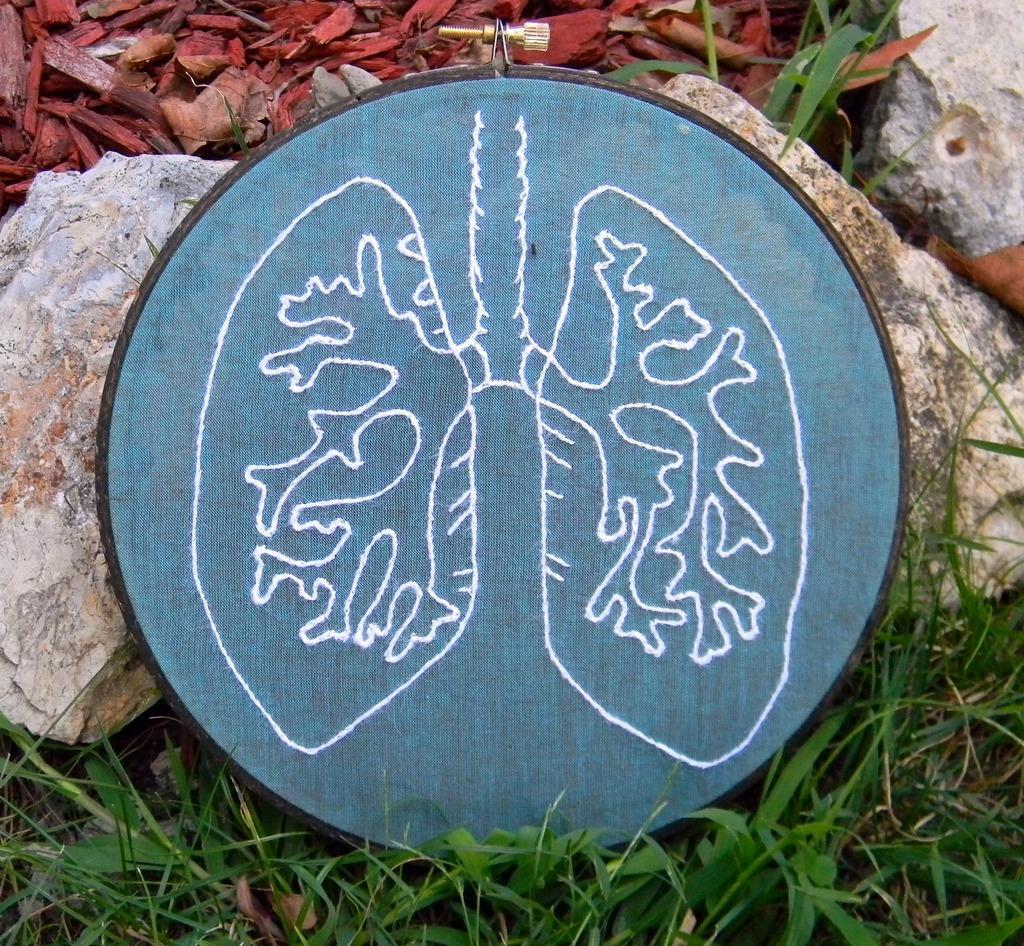Please provide a concise description of this image. In this image, we can see thread work on the ring frame hoop and in the background, there are rocks, grass and we can see sawdust. 